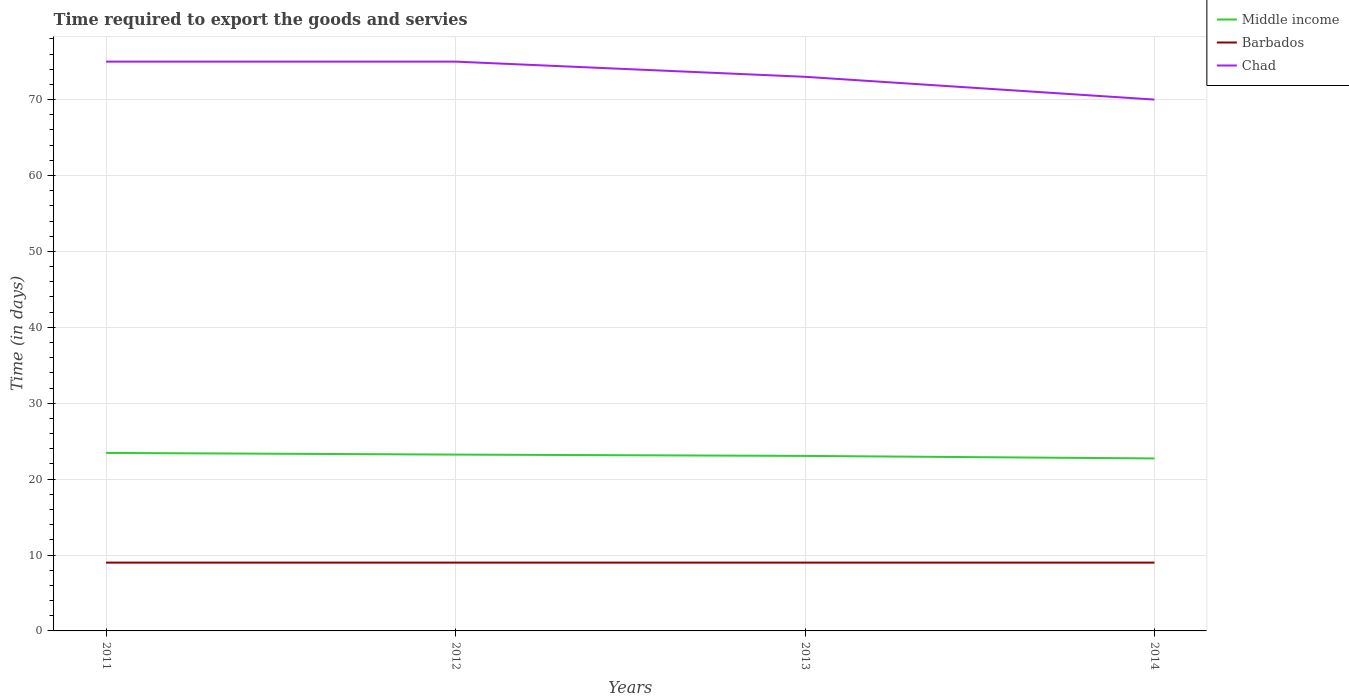Does the line corresponding to Barbados intersect with the line corresponding to Middle income?
Keep it short and to the point. No. Is the number of lines equal to the number of legend labels?
Give a very brief answer. Yes. Across all years, what is the maximum number of days required to export the goods and services in Middle income?
Your response must be concise. 22.72. What is the difference between the highest and the second highest number of days required to export the goods and services in Middle income?
Your answer should be compact. 0.72. Is the number of days required to export the goods and services in Middle income strictly greater than the number of days required to export the goods and services in Barbados over the years?
Ensure brevity in your answer.  No. How many lines are there?
Ensure brevity in your answer.  3. How many years are there in the graph?
Offer a terse response. 4. Are the values on the major ticks of Y-axis written in scientific E-notation?
Ensure brevity in your answer.  No. Does the graph contain grids?
Your answer should be compact. Yes. What is the title of the graph?
Ensure brevity in your answer.  Time required to export the goods and servies. Does "Georgia" appear as one of the legend labels in the graph?
Offer a terse response. No. What is the label or title of the Y-axis?
Give a very brief answer. Time (in days). What is the Time (in days) of Middle income in 2011?
Ensure brevity in your answer.  23.45. What is the Time (in days) of Middle income in 2012?
Make the answer very short. 23.23. What is the Time (in days) of Chad in 2012?
Your answer should be compact. 75. What is the Time (in days) of Middle income in 2013?
Keep it short and to the point. 23.06. What is the Time (in days) of Barbados in 2013?
Provide a succinct answer. 9. What is the Time (in days) in Chad in 2013?
Offer a terse response. 73. What is the Time (in days) in Middle income in 2014?
Your answer should be compact. 22.72. Across all years, what is the maximum Time (in days) in Middle income?
Make the answer very short. 23.45. Across all years, what is the maximum Time (in days) in Chad?
Make the answer very short. 75. Across all years, what is the minimum Time (in days) in Middle income?
Your answer should be compact. 22.72. Across all years, what is the minimum Time (in days) in Barbados?
Make the answer very short. 9. Across all years, what is the minimum Time (in days) of Chad?
Ensure brevity in your answer.  70. What is the total Time (in days) in Middle income in the graph?
Offer a very short reply. 92.46. What is the total Time (in days) in Chad in the graph?
Provide a short and direct response. 293. What is the difference between the Time (in days) in Middle income in 2011 and that in 2012?
Your response must be concise. 0.22. What is the difference between the Time (in days) in Barbados in 2011 and that in 2012?
Your response must be concise. 0. What is the difference between the Time (in days) in Middle income in 2011 and that in 2013?
Your answer should be compact. 0.39. What is the difference between the Time (in days) in Middle income in 2011 and that in 2014?
Provide a succinct answer. 0.72. What is the difference between the Time (in days) of Middle income in 2012 and that in 2013?
Provide a succinct answer. 0.17. What is the difference between the Time (in days) of Middle income in 2012 and that in 2014?
Give a very brief answer. 0.51. What is the difference between the Time (in days) of Middle income in 2013 and that in 2014?
Give a very brief answer. 0.33. What is the difference between the Time (in days) of Middle income in 2011 and the Time (in days) of Barbados in 2012?
Ensure brevity in your answer.  14.45. What is the difference between the Time (in days) of Middle income in 2011 and the Time (in days) of Chad in 2012?
Provide a short and direct response. -51.55. What is the difference between the Time (in days) of Barbados in 2011 and the Time (in days) of Chad in 2012?
Your response must be concise. -66. What is the difference between the Time (in days) of Middle income in 2011 and the Time (in days) of Barbados in 2013?
Ensure brevity in your answer.  14.45. What is the difference between the Time (in days) in Middle income in 2011 and the Time (in days) in Chad in 2013?
Offer a terse response. -49.55. What is the difference between the Time (in days) in Barbados in 2011 and the Time (in days) in Chad in 2013?
Give a very brief answer. -64. What is the difference between the Time (in days) in Middle income in 2011 and the Time (in days) in Barbados in 2014?
Provide a short and direct response. 14.45. What is the difference between the Time (in days) in Middle income in 2011 and the Time (in days) in Chad in 2014?
Provide a succinct answer. -46.55. What is the difference between the Time (in days) in Barbados in 2011 and the Time (in days) in Chad in 2014?
Provide a succinct answer. -61. What is the difference between the Time (in days) of Middle income in 2012 and the Time (in days) of Barbados in 2013?
Provide a succinct answer. 14.23. What is the difference between the Time (in days) in Middle income in 2012 and the Time (in days) in Chad in 2013?
Offer a terse response. -49.77. What is the difference between the Time (in days) in Barbados in 2012 and the Time (in days) in Chad in 2013?
Your answer should be compact. -64. What is the difference between the Time (in days) in Middle income in 2012 and the Time (in days) in Barbados in 2014?
Provide a short and direct response. 14.23. What is the difference between the Time (in days) of Middle income in 2012 and the Time (in days) of Chad in 2014?
Provide a succinct answer. -46.77. What is the difference between the Time (in days) of Barbados in 2012 and the Time (in days) of Chad in 2014?
Offer a terse response. -61. What is the difference between the Time (in days) of Middle income in 2013 and the Time (in days) of Barbados in 2014?
Keep it short and to the point. 14.06. What is the difference between the Time (in days) of Middle income in 2013 and the Time (in days) of Chad in 2014?
Your response must be concise. -46.94. What is the difference between the Time (in days) in Barbados in 2013 and the Time (in days) in Chad in 2014?
Make the answer very short. -61. What is the average Time (in days) in Middle income per year?
Give a very brief answer. 23.11. What is the average Time (in days) of Barbados per year?
Offer a very short reply. 9. What is the average Time (in days) of Chad per year?
Keep it short and to the point. 73.25. In the year 2011, what is the difference between the Time (in days) of Middle income and Time (in days) of Barbados?
Ensure brevity in your answer.  14.45. In the year 2011, what is the difference between the Time (in days) of Middle income and Time (in days) of Chad?
Ensure brevity in your answer.  -51.55. In the year 2011, what is the difference between the Time (in days) in Barbados and Time (in days) in Chad?
Your answer should be compact. -66. In the year 2012, what is the difference between the Time (in days) in Middle income and Time (in days) in Barbados?
Keep it short and to the point. 14.23. In the year 2012, what is the difference between the Time (in days) of Middle income and Time (in days) of Chad?
Ensure brevity in your answer.  -51.77. In the year 2012, what is the difference between the Time (in days) of Barbados and Time (in days) of Chad?
Ensure brevity in your answer.  -66. In the year 2013, what is the difference between the Time (in days) of Middle income and Time (in days) of Barbados?
Keep it short and to the point. 14.06. In the year 2013, what is the difference between the Time (in days) of Middle income and Time (in days) of Chad?
Ensure brevity in your answer.  -49.94. In the year 2013, what is the difference between the Time (in days) in Barbados and Time (in days) in Chad?
Ensure brevity in your answer.  -64. In the year 2014, what is the difference between the Time (in days) of Middle income and Time (in days) of Barbados?
Your response must be concise. 13.72. In the year 2014, what is the difference between the Time (in days) of Middle income and Time (in days) of Chad?
Keep it short and to the point. -47.28. In the year 2014, what is the difference between the Time (in days) in Barbados and Time (in days) in Chad?
Provide a short and direct response. -61. What is the ratio of the Time (in days) in Middle income in 2011 to that in 2012?
Provide a short and direct response. 1.01. What is the ratio of the Time (in days) of Chad in 2011 to that in 2012?
Make the answer very short. 1. What is the ratio of the Time (in days) of Middle income in 2011 to that in 2013?
Keep it short and to the point. 1.02. What is the ratio of the Time (in days) of Barbados in 2011 to that in 2013?
Provide a succinct answer. 1. What is the ratio of the Time (in days) of Chad in 2011 to that in 2013?
Your answer should be very brief. 1.03. What is the ratio of the Time (in days) of Middle income in 2011 to that in 2014?
Provide a short and direct response. 1.03. What is the ratio of the Time (in days) in Barbados in 2011 to that in 2014?
Your answer should be very brief. 1. What is the ratio of the Time (in days) of Chad in 2011 to that in 2014?
Your answer should be compact. 1.07. What is the ratio of the Time (in days) of Middle income in 2012 to that in 2013?
Offer a terse response. 1.01. What is the ratio of the Time (in days) of Chad in 2012 to that in 2013?
Your answer should be very brief. 1.03. What is the ratio of the Time (in days) of Middle income in 2012 to that in 2014?
Make the answer very short. 1.02. What is the ratio of the Time (in days) in Chad in 2012 to that in 2014?
Give a very brief answer. 1.07. What is the ratio of the Time (in days) of Middle income in 2013 to that in 2014?
Your response must be concise. 1.01. What is the ratio of the Time (in days) in Barbados in 2013 to that in 2014?
Provide a short and direct response. 1. What is the ratio of the Time (in days) of Chad in 2013 to that in 2014?
Your response must be concise. 1.04. What is the difference between the highest and the second highest Time (in days) in Middle income?
Offer a terse response. 0.22. What is the difference between the highest and the second highest Time (in days) of Barbados?
Offer a very short reply. 0. What is the difference between the highest and the lowest Time (in days) of Middle income?
Provide a succinct answer. 0.72. What is the difference between the highest and the lowest Time (in days) of Barbados?
Your answer should be compact. 0. What is the difference between the highest and the lowest Time (in days) of Chad?
Your response must be concise. 5. 